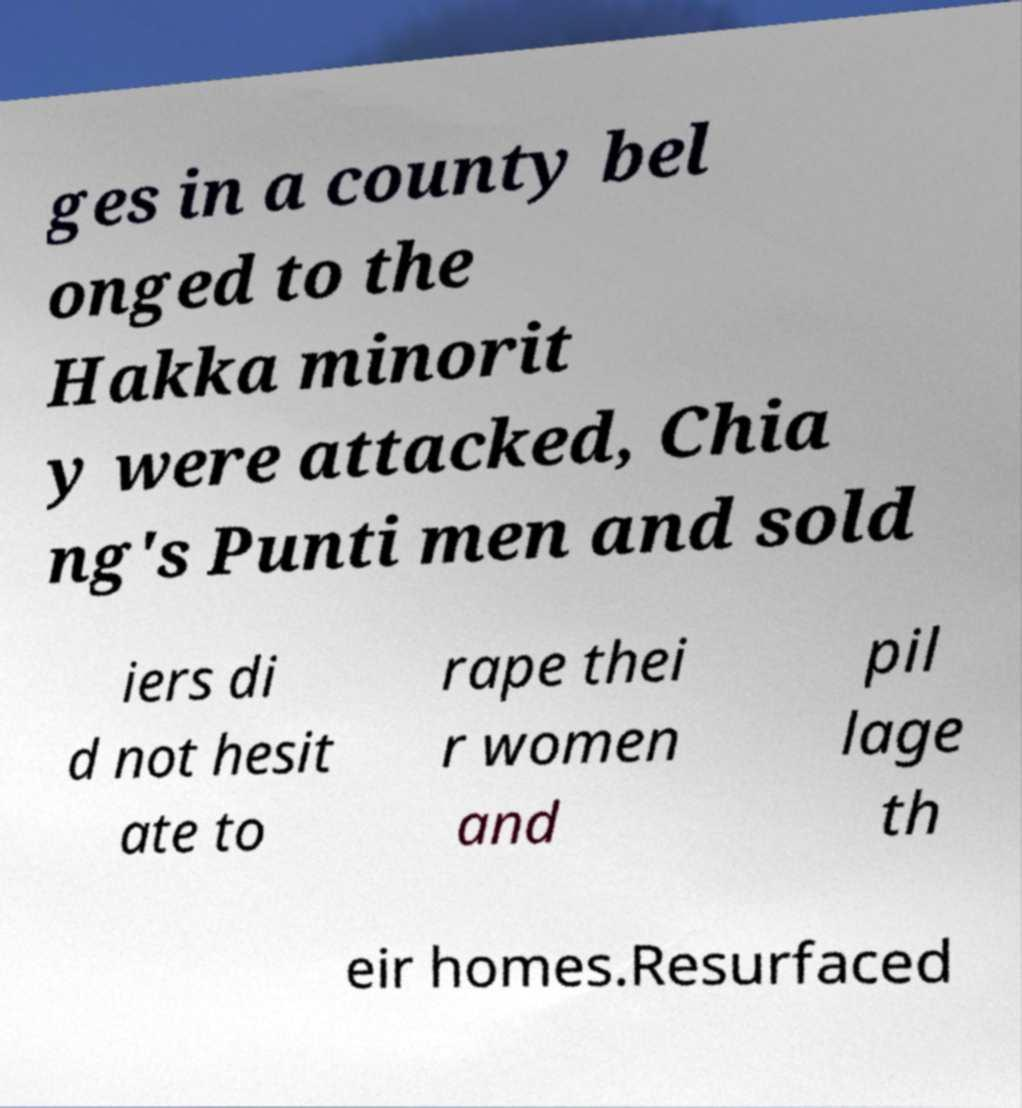For documentation purposes, I need the text within this image transcribed. Could you provide that? ges in a county bel onged to the Hakka minorit y were attacked, Chia ng's Punti men and sold iers di d not hesit ate to rape thei r women and pil lage th eir homes.Resurfaced 